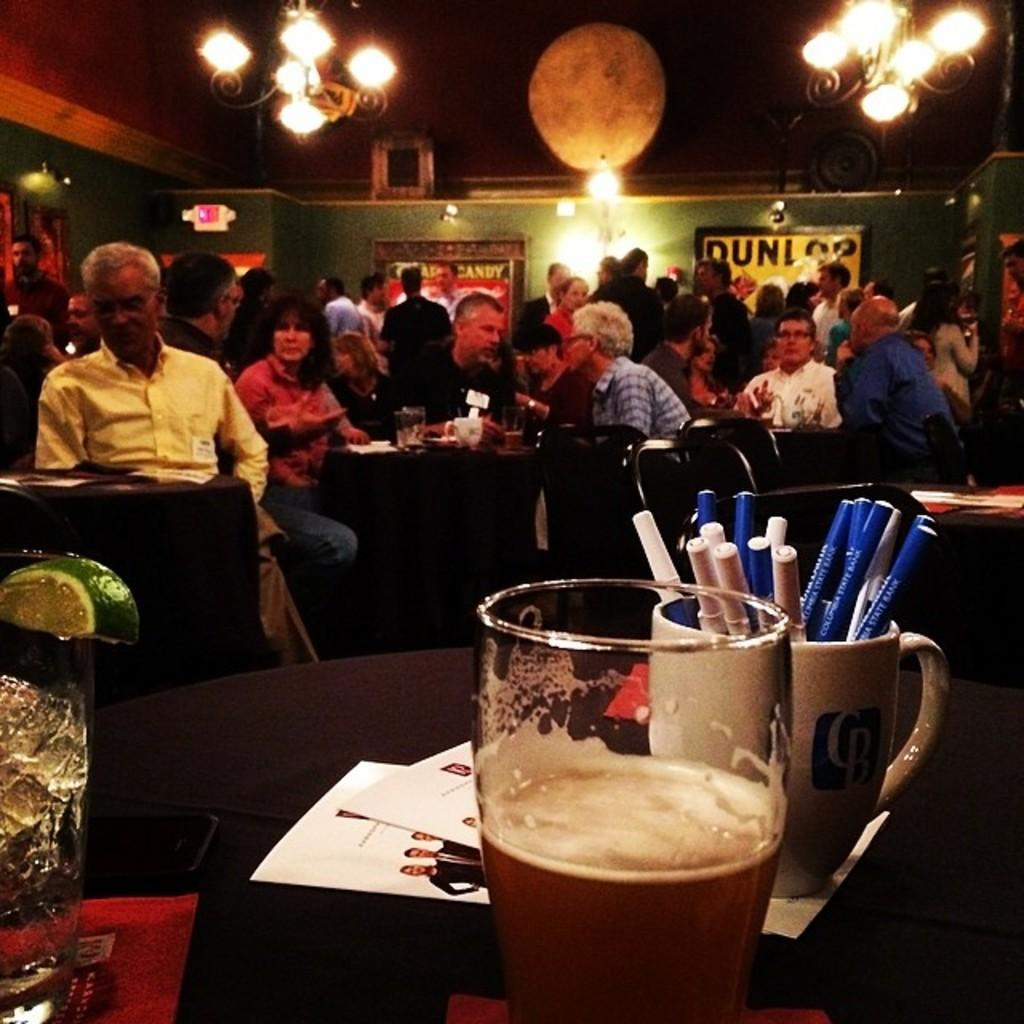<image>
Create a compact narrative representing the image presented. A bar with a dunlop poster on the wall is crowded with people. 